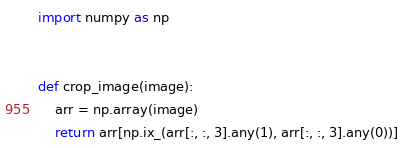Convert code to text. <code><loc_0><loc_0><loc_500><loc_500><_Python_>import numpy as np


def crop_image(image):
    arr = np.array(image)
    return arr[np.ix_(arr[:, :, 3].any(1), arr[:, :, 3].any(0))]
</code> 